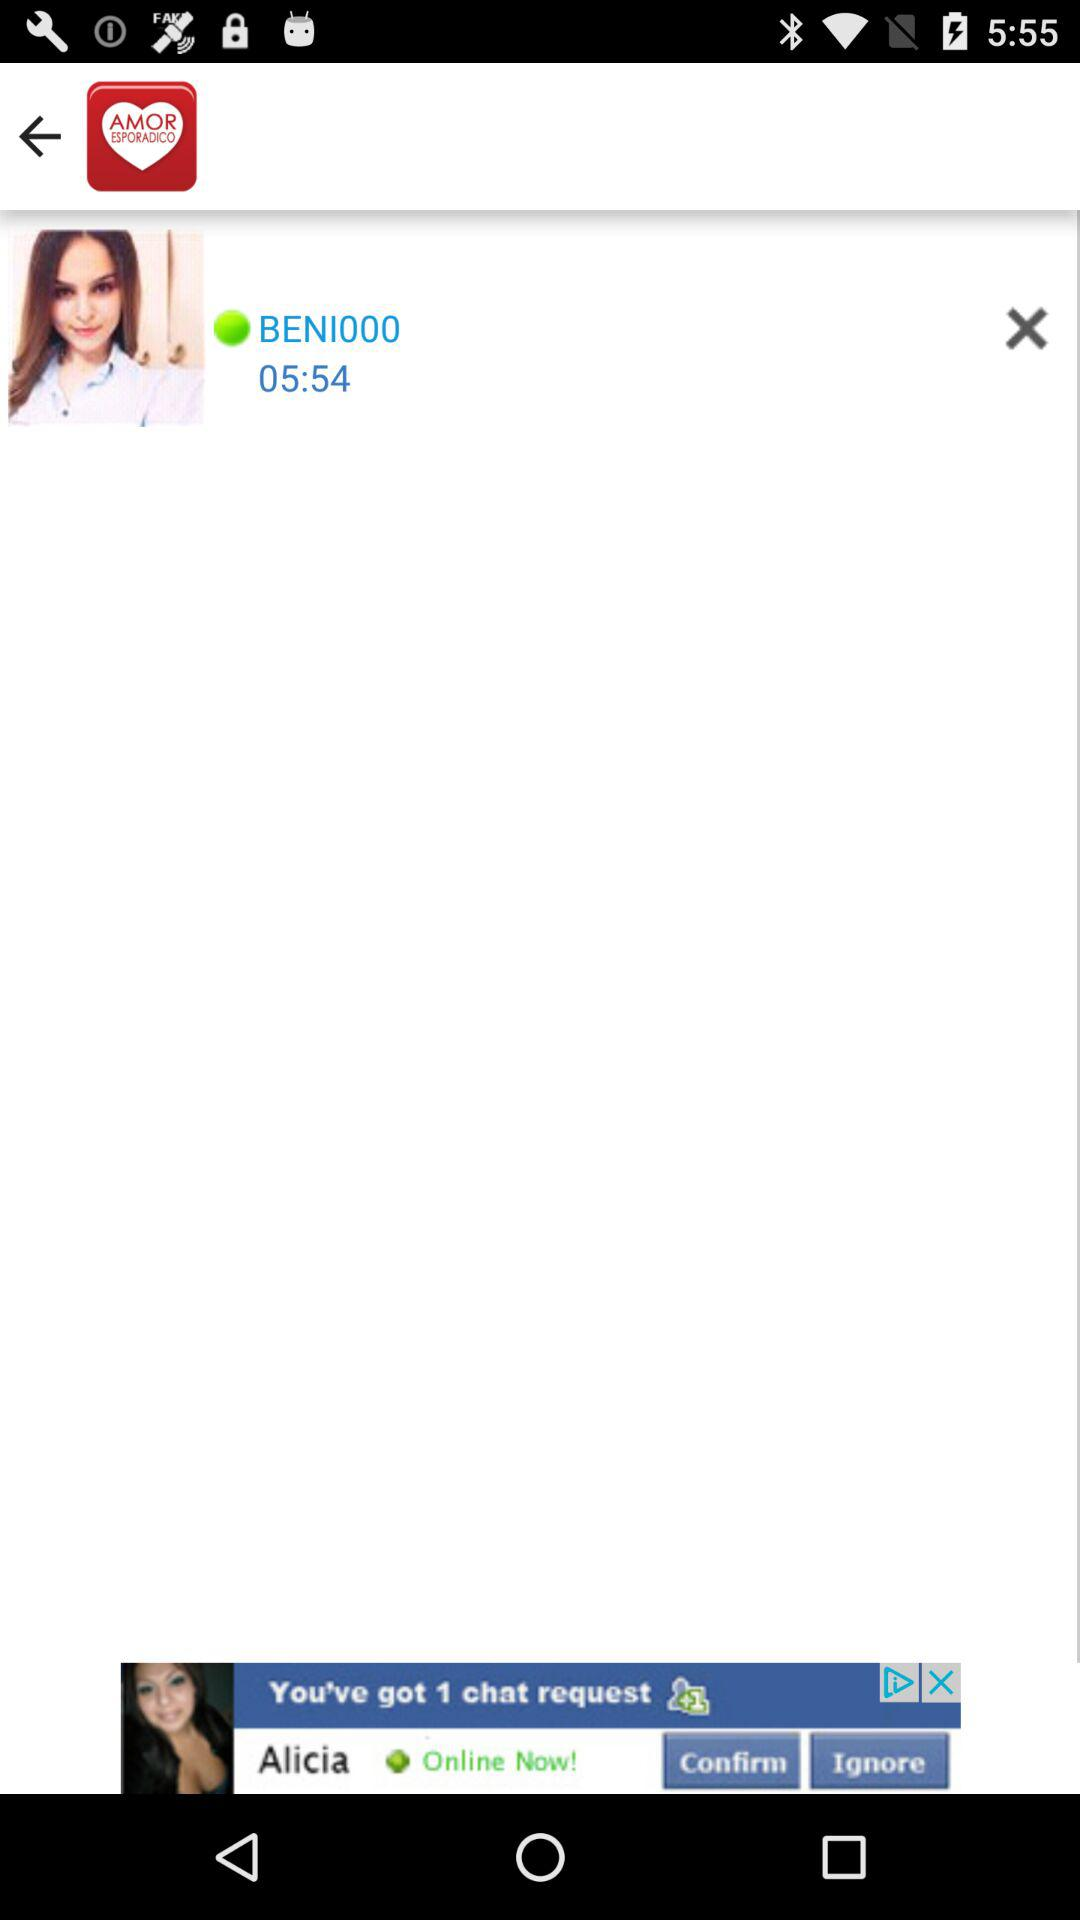At what time is the user online? The user is online at 5:54. 